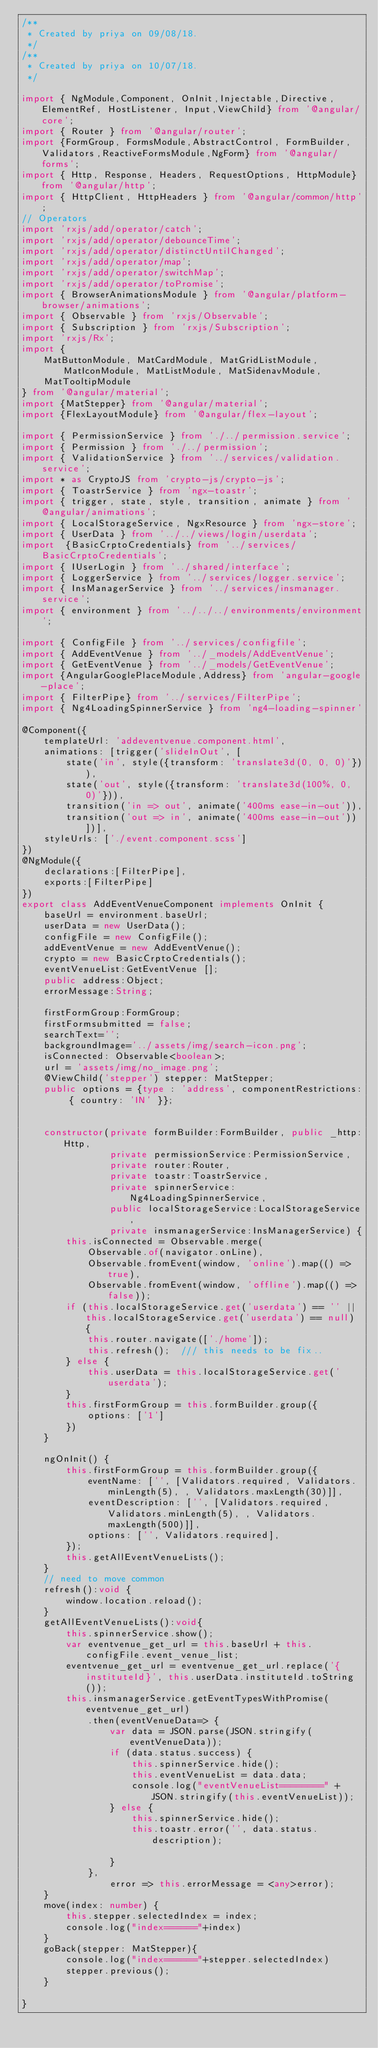<code> <loc_0><loc_0><loc_500><loc_500><_TypeScript_>/**
 * Created by priya on 09/08/18.
 */
/**
 * Created by priya on 10/07/18.
 */

import { NgModule,Component, OnInit,Injectable,Directive, ElementRef, HostListener, Input,ViewChild} from '@angular/core';
import { Router } from '@angular/router';
import {FormGroup, FormsModule,AbstractControl, FormBuilder, Validators,ReactiveFormsModule,NgForm} from '@angular/forms';
import { Http, Response, Headers, RequestOptions, HttpModule} from '@angular/http';
import { HttpClient, HttpHeaders } from '@angular/common/http';
// Operators
import 'rxjs/add/operator/catch';
import 'rxjs/add/operator/debounceTime';
import 'rxjs/add/operator/distinctUntilChanged';
import 'rxjs/add/operator/map';
import 'rxjs/add/operator/switchMap';
import 'rxjs/add/operator/toPromise';
import { BrowserAnimationsModule } from '@angular/platform-browser/animations';
import { Observable } from 'rxjs/Observable';
import { Subscription } from 'rxjs/Subscription';
import 'rxjs/Rx';
import {
    MatButtonModule, MatCardModule, MatGridListModule, MatIconModule, MatListModule, MatSidenavModule,
    MatTooltipModule
} from '@angular/material';
import {MatStepper} from '@angular/material';
import {FlexLayoutModule} from '@angular/flex-layout';

import { PermissionService } from './../permission.service';
import { Permission } from './../permission';
import { ValidationService } from '../services/validation.service';
import * as CryptoJS from 'crypto-js/crypto-js';
import { ToastrService } from 'ngx-toastr';
import { trigger, state, style, transition, animate } from '@angular/animations';
import { LocalStorageService, NgxResource } from 'ngx-store';
import { UserData } from '../../views/login/userdata';
import  {BasicCrptoCredentials} from '../services/BasicCrptoCredentials';
import { IUserLogin } from '../shared/interface';
import { LoggerService } from '../services/logger.service';
import { InsManagerService } from '../services/insmanager.service';
import { environment } from '../../../environments/environment';

import { ConfigFile } from '../services/configfile';
import { AddEventVenue } from '../_models/AddEventVenue';
import { GetEventVenue } from '../_models/GetEventVenue';
import {AngularGooglePlaceModule,Address} from 'angular-google-place';
import { FilterPipe} from '../services/FilterPipe';
import { Ng4LoadingSpinnerService } from 'ng4-loading-spinner'

@Component({
    templateUrl: 'addeventvenue.component.html',
    animations: [trigger('slideInOut', [
        state('in', style({transform: 'translate3d(0, 0, 0)'})),
        state('out', style({transform: 'translate3d(100%, 0, 0)'})),
        transition('in => out', animate('400ms ease-in-out')),
        transition('out => in', animate('400ms ease-in-out'))])],
    styleUrls: ['./event.component.scss']
})
@NgModule({
    declarations:[FilterPipe],
    exports:[FilterPipe]
})
export class AddEventVenueComponent implements OnInit {
    baseUrl = environment.baseUrl;
    userData = new UserData();
    configFile = new ConfigFile();
    addEventVenue = new AddEventVenue();
    crypto = new BasicCrptoCredentials();
    eventVenueList:GetEventVenue [];
    public address:Object;
    errorMessage:String;

    firstFormGroup:FormGroup;
    firstFormsubmitted = false;
    searchText='';
    backgroundImage='../assets/img/search-icon.png';
    isConnected: Observable<boolean>;
    url = 'assets/img/no_image.png';
    @ViewChild('stepper') stepper: MatStepper;
    public options = {type : 'address', componentRestrictions: { country: 'IN' }};


    constructor(private formBuilder:FormBuilder, public _http:Http,
                private permissionService:PermissionService,
                private router:Router,
                private toastr:ToastrService,
                private spinnerService:Ng4LoadingSpinnerService,
                public localStorageService:LocalStorageService,
                private insmanagerService:InsManagerService) {
        this.isConnected = Observable.merge(
            Observable.of(navigator.onLine),
            Observable.fromEvent(window, 'online').map(() => true),
            Observable.fromEvent(window, 'offline').map(() => false));
        if (this.localStorageService.get('userdata') == '' || this.localStorageService.get('userdata') == null) {
            this.router.navigate(['./home']);
            this.refresh();  /// this needs to be fix..
        } else {
            this.userData = this.localStorageService.get('userdata');
        }
        this.firstFormGroup = this.formBuilder.group({
            options: ['1']
        })
    }

    ngOnInit() {
        this.firstFormGroup = this.formBuilder.group({
            eventName: ['', [Validators.required, Validators.minLength(5), , Validators.maxLength(30)]],
            eventDescription: ['', [Validators.required, Validators.minLength(5), , Validators.maxLength(500)]],
            options: ['', Validators.required],
        });
        this.getAllEventVenueLists();
    }
    // need to move common
    refresh():void {
        window.location.reload();
    }
    getAllEventVenueLists():void{
        this.spinnerService.show();
        var eventvenue_get_url = this.baseUrl + this.configFile.event_venue_list;
        eventvenue_get_url = eventvenue_get_url.replace('{instituteId}', this.userData.instituteId.toString());
        this.insmanagerService.getEventTypesWithPromise(eventvenue_get_url)
            .then(eventVenueData=> {
                var data = JSON.parse(JSON.stringify(eventVenueData));
                if (data.status.success) {
                    this.spinnerService.hide();
                    this.eventVenueList = data.data;
                    console.log("eventVenueList========" + JSON.stringify(this.eventVenueList));
                } else {
                    this.spinnerService.hide();
                    this.toastr.error('', data.status.description);

                }
            },
                error => this.errorMessage = <any>error);
    }
    move(index: number) {
        this.stepper.selectedIndex = index;
        console.log("index======"+index)
    }
    goBack(stepper: MatStepper){
        console.log("index======"+stepper.selectedIndex)
        stepper.previous();
    }

}</code> 